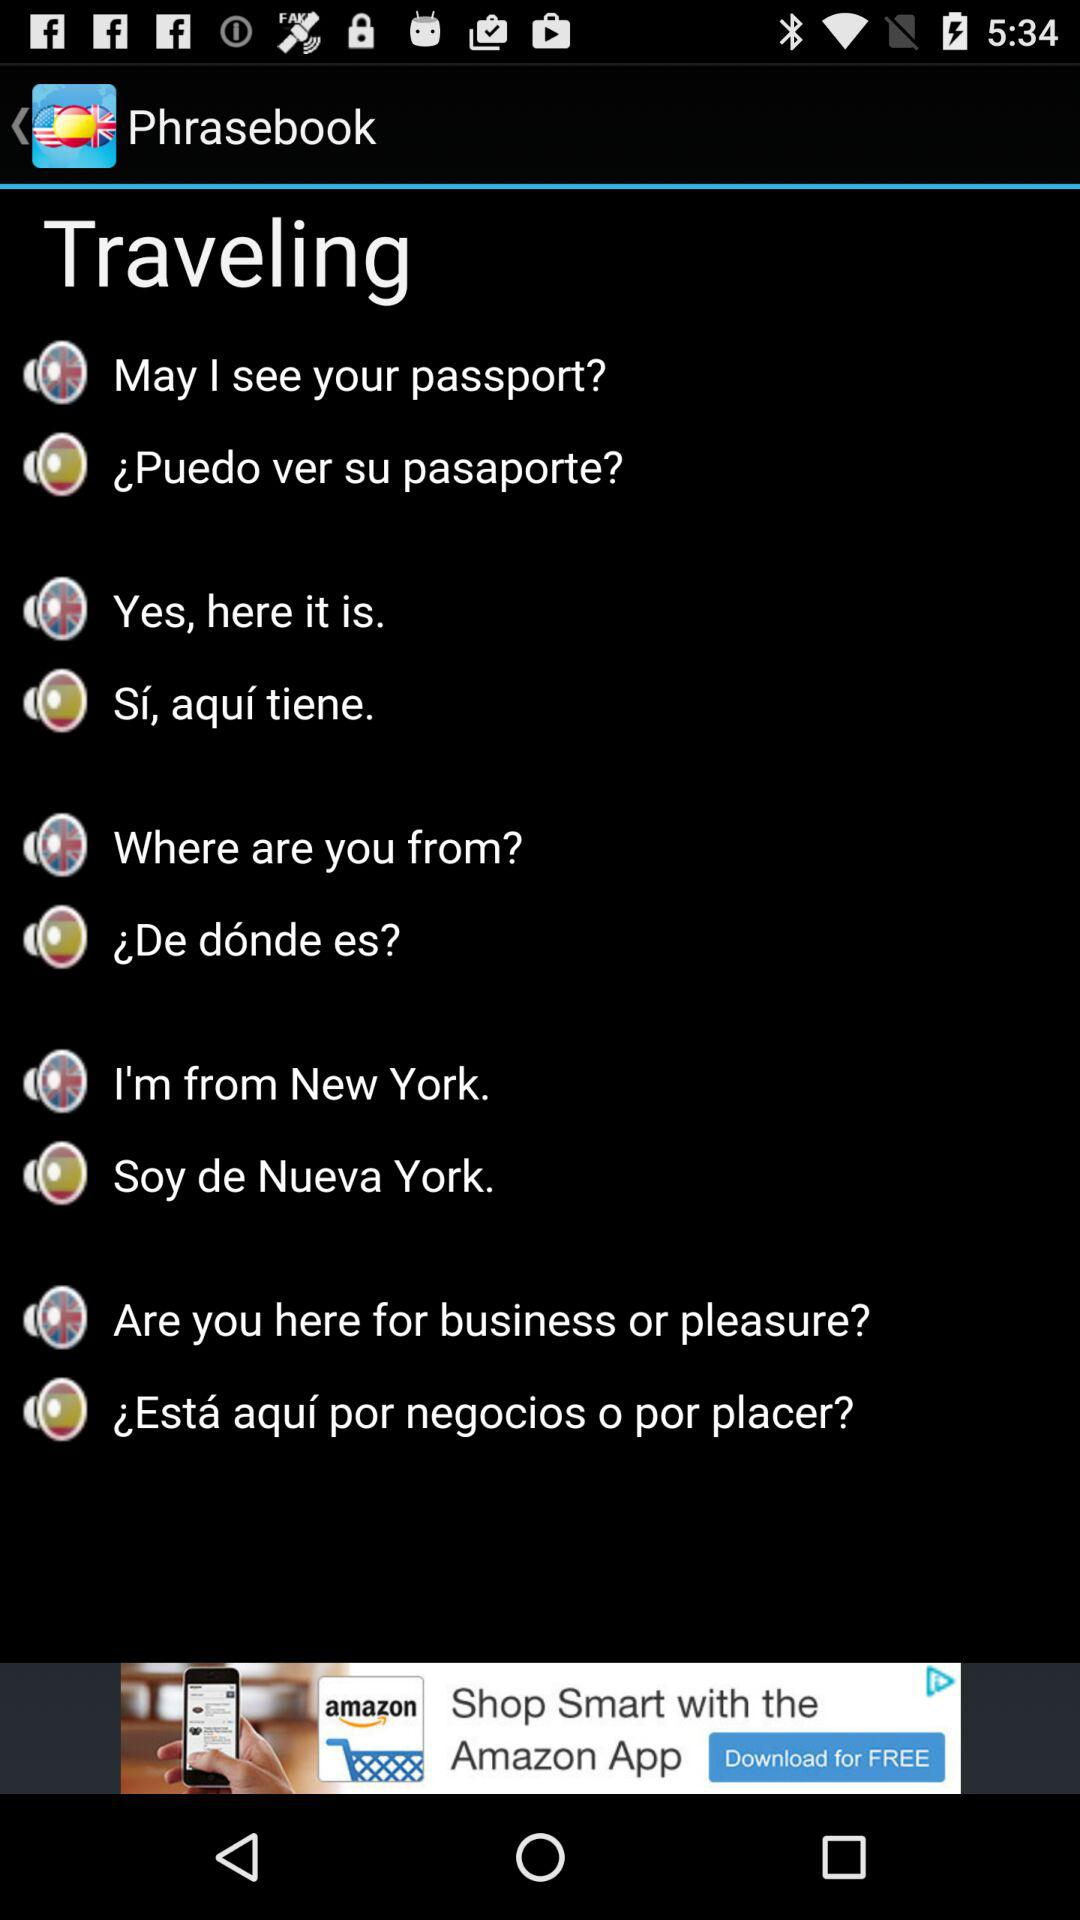What is the name of the application? The name of the application is "Phrasebook". 